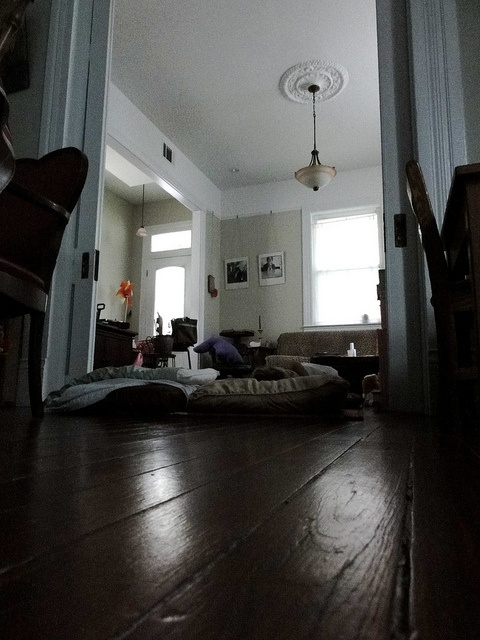Describe the objects in this image and their specific colors. I can see bed in black and gray tones, chair in black, gray, and purple tones, chair in black and gray tones, couch in black and gray tones, and chair in black, gray, and darkgray tones in this image. 